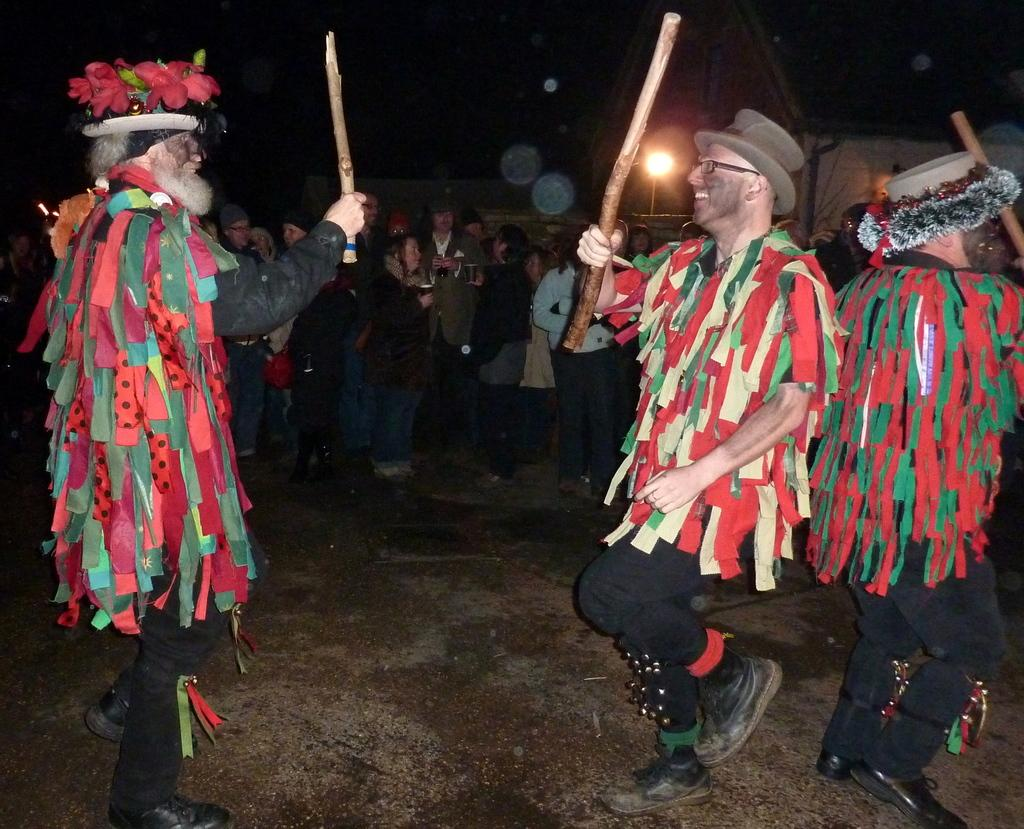How many people are in the image? There are three persons in the image. What are the three persons wearing? The three persons are wearing fancy dresses. What are the three persons doing in the image? They are standing and smiling. What are the three persons holding in the image? They are holding sticks. What can be seen in the background of the image? There is a group of people and a house in the background of the image. What song is the group of people in the background singing in the image? There is no indication in the image that the group of people in the background is singing a song. 